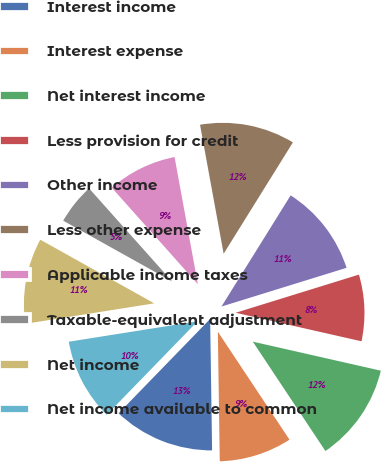<chart> <loc_0><loc_0><loc_500><loc_500><pie_chart><fcel>Interest income<fcel>Interest expense<fcel>Net interest income<fcel>Less provision for credit<fcel>Other income<fcel>Less other expense<fcel>Applicable income taxes<fcel>Taxable-equivalent adjustment<fcel>Net income<fcel>Net income available to common<nl><fcel>12.5%<fcel>9.09%<fcel>12.12%<fcel>8.33%<fcel>11.36%<fcel>11.74%<fcel>8.71%<fcel>5.3%<fcel>10.61%<fcel>10.23%<nl></chart> 